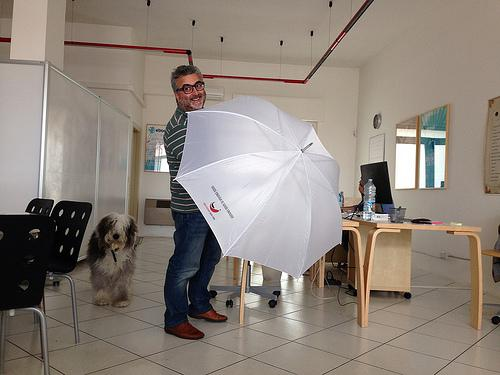Question: where was the photo taken?
Choices:
A. Living room.
B. Restaurant.
C. Movie theatre.
D. Office.
Answer with the letter. Answer: D Question: how many people are there?
Choices:
A. Two.
B. One.
C. Three.
D. Four.
Answer with the letter. Answer: B Question: who is holding an umbrella?
Choices:
A. The little girl.
B. The old woman.
C. The young lady.
D. The man.
Answer with the letter. Answer: D 